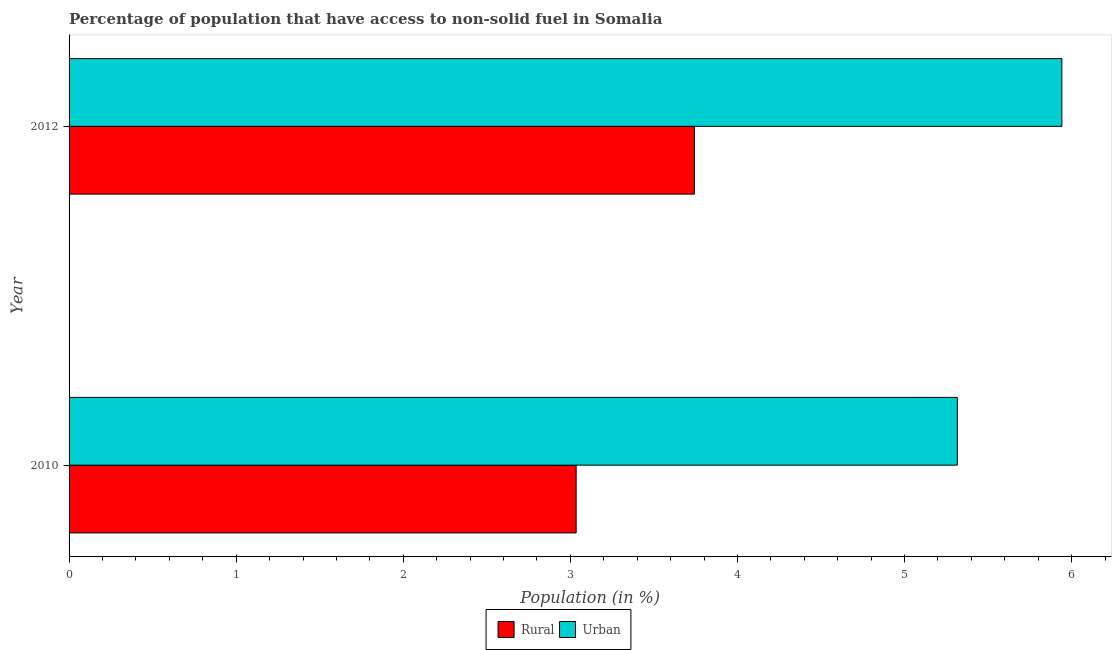How many different coloured bars are there?
Make the answer very short. 2. Are the number of bars on each tick of the Y-axis equal?
Provide a succinct answer. Yes. How many bars are there on the 1st tick from the top?
Your response must be concise. 2. How many bars are there on the 1st tick from the bottom?
Provide a short and direct response. 2. In how many cases, is the number of bars for a given year not equal to the number of legend labels?
Ensure brevity in your answer.  0. What is the rural population in 2012?
Give a very brief answer. 3.74. Across all years, what is the maximum urban population?
Give a very brief answer. 5.94. Across all years, what is the minimum urban population?
Your answer should be very brief. 5.32. What is the total rural population in the graph?
Your answer should be compact. 6.78. What is the difference between the rural population in 2010 and that in 2012?
Provide a short and direct response. -0.71. What is the difference between the urban population in 2010 and the rural population in 2012?
Ensure brevity in your answer.  1.57. What is the average rural population per year?
Ensure brevity in your answer.  3.39. In the year 2010, what is the difference between the rural population and urban population?
Provide a succinct answer. -2.28. In how many years, is the rural population greater than 0.4 %?
Give a very brief answer. 2. What is the ratio of the rural population in 2010 to that in 2012?
Your answer should be compact. 0.81. Is the urban population in 2010 less than that in 2012?
Offer a very short reply. Yes. Is the difference between the rural population in 2010 and 2012 greater than the difference between the urban population in 2010 and 2012?
Provide a succinct answer. No. In how many years, is the rural population greater than the average rural population taken over all years?
Your answer should be very brief. 1. What does the 2nd bar from the top in 2010 represents?
Offer a terse response. Rural. What does the 2nd bar from the bottom in 2012 represents?
Offer a very short reply. Urban. Are all the bars in the graph horizontal?
Your answer should be compact. Yes. What is the difference between two consecutive major ticks on the X-axis?
Make the answer very short. 1. Are the values on the major ticks of X-axis written in scientific E-notation?
Provide a short and direct response. No. What is the title of the graph?
Offer a terse response. Percentage of population that have access to non-solid fuel in Somalia. What is the label or title of the X-axis?
Make the answer very short. Population (in %). What is the label or title of the Y-axis?
Provide a succinct answer. Year. What is the Population (in %) of Rural in 2010?
Offer a very short reply. 3.03. What is the Population (in %) in Urban in 2010?
Make the answer very short. 5.32. What is the Population (in %) in Rural in 2012?
Provide a short and direct response. 3.74. What is the Population (in %) of Urban in 2012?
Your answer should be compact. 5.94. Across all years, what is the maximum Population (in %) of Rural?
Your answer should be very brief. 3.74. Across all years, what is the maximum Population (in %) in Urban?
Your answer should be very brief. 5.94. Across all years, what is the minimum Population (in %) in Rural?
Keep it short and to the point. 3.03. Across all years, what is the minimum Population (in %) of Urban?
Give a very brief answer. 5.32. What is the total Population (in %) of Rural in the graph?
Offer a terse response. 6.78. What is the total Population (in %) of Urban in the graph?
Your response must be concise. 11.26. What is the difference between the Population (in %) of Rural in 2010 and that in 2012?
Your response must be concise. -0.71. What is the difference between the Population (in %) in Urban in 2010 and that in 2012?
Offer a very short reply. -0.63. What is the difference between the Population (in %) of Rural in 2010 and the Population (in %) of Urban in 2012?
Ensure brevity in your answer.  -2.91. What is the average Population (in %) of Rural per year?
Provide a succinct answer. 3.39. What is the average Population (in %) of Urban per year?
Give a very brief answer. 5.63. In the year 2010, what is the difference between the Population (in %) in Rural and Population (in %) in Urban?
Your answer should be very brief. -2.28. In the year 2012, what is the difference between the Population (in %) of Rural and Population (in %) of Urban?
Keep it short and to the point. -2.2. What is the ratio of the Population (in %) in Rural in 2010 to that in 2012?
Your response must be concise. 0.81. What is the ratio of the Population (in %) in Urban in 2010 to that in 2012?
Your answer should be compact. 0.89. What is the difference between the highest and the second highest Population (in %) in Rural?
Keep it short and to the point. 0.71. What is the difference between the highest and the second highest Population (in %) in Urban?
Ensure brevity in your answer.  0.63. What is the difference between the highest and the lowest Population (in %) of Rural?
Give a very brief answer. 0.71. What is the difference between the highest and the lowest Population (in %) of Urban?
Make the answer very short. 0.63. 